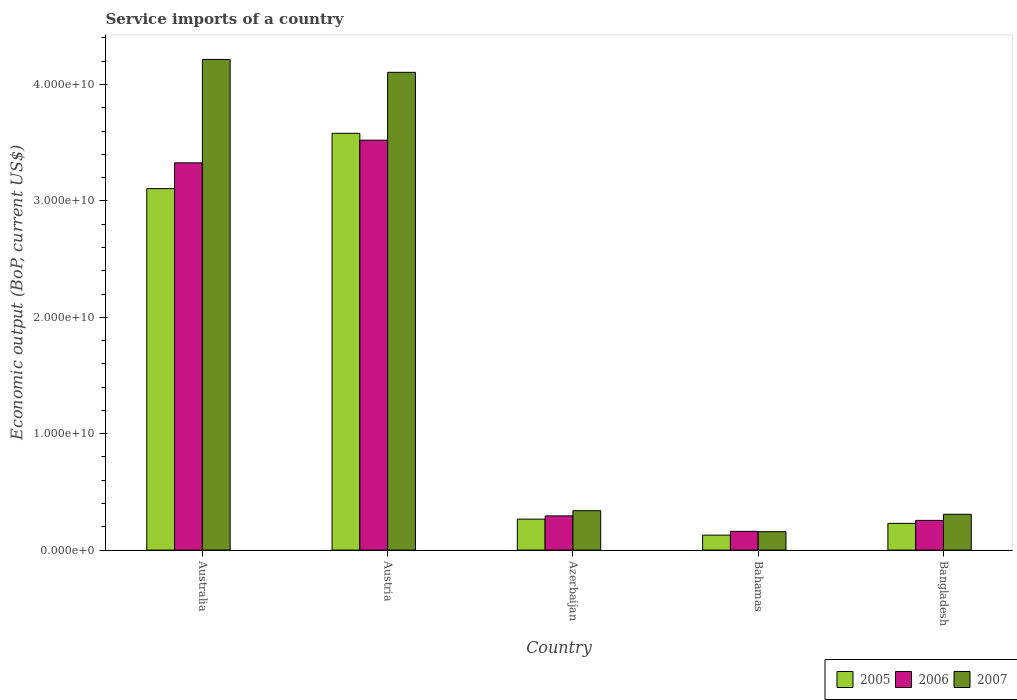How many different coloured bars are there?
Make the answer very short. 3. Are the number of bars per tick equal to the number of legend labels?
Give a very brief answer. Yes. How many bars are there on the 5th tick from the left?
Keep it short and to the point. 3. How many bars are there on the 2nd tick from the right?
Make the answer very short. 3. What is the label of the 1st group of bars from the left?
Offer a very short reply. Australia. What is the service imports in 2005 in Bangladesh?
Your response must be concise. 2.30e+09. Across all countries, what is the maximum service imports in 2007?
Offer a very short reply. 4.22e+1. Across all countries, what is the minimum service imports in 2006?
Your response must be concise. 1.61e+09. In which country was the service imports in 2005 minimum?
Provide a short and direct response. Bahamas. What is the total service imports in 2006 in the graph?
Provide a short and direct response. 7.56e+1. What is the difference between the service imports in 2007 in Austria and that in Bangladesh?
Provide a succinct answer. 3.80e+1. What is the difference between the service imports in 2007 in Azerbaijan and the service imports in 2006 in Bangladesh?
Make the answer very short. 8.32e+08. What is the average service imports in 2006 per country?
Keep it short and to the point. 1.51e+1. What is the difference between the service imports of/in 2005 and service imports of/in 2006 in Bahamas?
Your answer should be compact. -3.24e+08. In how many countries, is the service imports in 2007 greater than 2000000000 US$?
Provide a succinct answer. 4. What is the ratio of the service imports in 2007 in Azerbaijan to that in Bangladesh?
Your answer should be compact. 1.1. Is the difference between the service imports in 2005 in Australia and Bangladesh greater than the difference between the service imports in 2006 in Australia and Bangladesh?
Provide a short and direct response. No. What is the difference between the highest and the second highest service imports in 2006?
Provide a short and direct response. 3.23e+1. What is the difference between the highest and the lowest service imports in 2006?
Give a very brief answer. 3.36e+1. In how many countries, is the service imports in 2005 greater than the average service imports in 2005 taken over all countries?
Make the answer very short. 2. Is the sum of the service imports in 2005 in Australia and Bahamas greater than the maximum service imports in 2006 across all countries?
Give a very brief answer. No. Is it the case that in every country, the sum of the service imports in 2006 and service imports in 2007 is greater than the service imports in 2005?
Provide a succinct answer. Yes. What is the difference between two consecutive major ticks on the Y-axis?
Provide a succinct answer. 1.00e+1. Are the values on the major ticks of Y-axis written in scientific E-notation?
Provide a short and direct response. Yes. Does the graph contain any zero values?
Your response must be concise. No. Does the graph contain grids?
Your response must be concise. No. How many legend labels are there?
Ensure brevity in your answer.  3. How are the legend labels stacked?
Make the answer very short. Horizontal. What is the title of the graph?
Your answer should be very brief. Service imports of a country. What is the label or title of the Y-axis?
Your answer should be very brief. Economic output (BoP, current US$). What is the Economic output (BoP, current US$) in 2005 in Australia?
Your response must be concise. 3.11e+1. What is the Economic output (BoP, current US$) in 2006 in Australia?
Ensure brevity in your answer.  3.33e+1. What is the Economic output (BoP, current US$) in 2007 in Australia?
Keep it short and to the point. 4.22e+1. What is the Economic output (BoP, current US$) in 2005 in Austria?
Provide a succinct answer. 3.58e+1. What is the Economic output (BoP, current US$) of 2006 in Austria?
Offer a terse response. 3.52e+1. What is the Economic output (BoP, current US$) in 2007 in Austria?
Keep it short and to the point. 4.10e+1. What is the Economic output (BoP, current US$) of 2005 in Azerbaijan?
Your answer should be very brief. 2.66e+09. What is the Economic output (BoP, current US$) in 2006 in Azerbaijan?
Provide a succinct answer. 2.94e+09. What is the Economic output (BoP, current US$) in 2007 in Azerbaijan?
Provide a succinct answer. 3.39e+09. What is the Economic output (BoP, current US$) of 2005 in Bahamas?
Your answer should be compact. 1.29e+09. What is the Economic output (BoP, current US$) in 2006 in Bahamas?
Your response must be concise. 1.61e+09. What is the Economic output (BoP, current US$) of 2007 in Bahamas?
Provide a short and direct response. 1.58e+09. What is the Economic output (BoP, current US$) of 2005 in Bangladesh?
Your response must be concise. 2.30e+09. What is the Economic output (BoP, current US$) of 2006 in Bangladesh?
Your answer should be very brief. 2.55e+09. What is the Economic output (BoP, current US$) in 2007 in Bangladesh?
Provide a succinct answer. 3.08e+09. Across all countries, what is the maximum Economic output (BoP, current US$) of 2005?
Offer a very short reply. 3.58e+1. Across all countries, what is the maximum Economic output (BoP, current US$) in 2006?
Your answer should be very brief. 3.52e+1. Across all countries, what is the maximum Economic output (BoP, current US$) of 2007?
Your answer should be very brief. 4.22e+1. Across all countries, what is the minimum Economic output (BoP, current US$) in 2005?
Make the answer very short. 1.29e+09. Across all countries, what is the minimum Economic output (BoP, current US$) in 2006?
Give a very brief answer. 1.61e+09. Across all countries, what is the minimum Economic output (BoP, current US$) in 2007?
Offer a terse response. 1.58e+09. What is the total Economic output (BoP, current US$) in 2005 in the graph?
Your answer should be compact. 7.31e+1. What is the total Economic output (BoP, current US$) in 2006 in the graph?
Keep it short and to the point. 7.56e+1. What is the total Economic output (BoP, current US$) of 2007 in the graph?
Provide a succinct answer. 9.12e+1. What is the difference between the Economic output (BoP, current US$) of 2005 in Australia and that in Austria?
Your answer should be compact. -4.75e+09. What is the difference between the Economic output (BoP, current US$) of 2006 in Australia and that in Austria?
Your answer should be compact. -1.95e+09. What is the difference between the Economic output (BoP, current US$) in 2007 in Australia and that in Austria?
Offer a terse response. 1.11e+09. What is the difference between the Economic output (BoP, current US$) of 2005 in Australia and that in Azerbaijan?
Provide a succinct answer. 2.84e+1. What is the difference between the Economic output (BoP, current US$) in 2006 in Australia and that in Azerbaijan?
Your answer should be compact. 3.03e+1. What is the difference between the Economic output (BoP, current US$) of 2007 in Australia and that in Azerbaijan?
Ensure brevity in your answer.  3.88e+1. What is the difference between the Economic output (BoP, current US$) of 2005 in Australia and that in Bahamas?
Offer a very short reply. 2.98e+1. What is the difference between the Economic output (BoP, current US$) in 2006 in Australia and that in Bahamas?
Your answer should be compact. 3.17e+1. What is the difference between the Economic output (BoP, current US$) of 2007 in Australia and that in Bahamas?
Your answer should be compact. 4.06e+1. What is the difference between the Economic output (BoP, current US$) in 2005 in Australia and that in Bangladesh?
Offer a terse response. 2.88e+1. What is the difference between the Economic output (BoP, current US$) in 2006 in Australia and that in Bangladesh?
Offer a terse response. 3.07e+1. What is the difference between the Economic output (BoP, current US$) in 2007 in Australia and that in Bangladesh?
Your answer should be very brief. 3.91e+1. What is the difference between the Economic output (BoP, current US$) in 2005 in Austria and that in Azerbaijan?
Make the answer very short. 3.31e+1. What is the difference between the Economic output (BoP, current US$) of 2006 in Austria and that in Azerbaijan?
Keep it short and to the point. 3.23e+1. What is the difference between the Economic output (BoP, current US$) of 2007 in Austria and that in Azerbaijan?
Ensure brevity in your answer.  3.77e+1. What is the difference between the Economic output (BoP, current US$) in 2005 in Austria and that in Bahamas?
Make the answer very short. 3.45e+1. What is the difference between the Economic output (BoP, current US$) of 2006 in Austria and that in Bahamas?
Make the answer very short. 3.36e+1. What is the difference between the Economic output (BoP, current US$) in 2007 in Austria and that in Bahamas?
Offer a very short reply. 3.95e+1. What is the difference between the Economic output (BoP, current US$) in 2005 in Austria and that in Bangladesh?
Provide a succinct answer. 3.35e+1. What is the difference between the Economic output (BoP, current US$) in 2006 in Austria and that in Bangladesh?
Ensure brevity in your answer.  3.27e+1. What is the difference between the Economic output (BoP, current US$) in 2007 in Austria and that in Bangladesh?
Offer a terse response. 3.80e+1. What is the difference between the Economic output (BoP, current US$) of 2005 in Azerbaijan and that in Bahamas?
Offer a very short reply. 1.37e+09. What is the difference between the Economic output (BoP, current US$) in 2006 in Azerbaijan and that in Bahamas?
Your response must be concise. 1.33e+09. What is the difference between the Economic output (BoP, current US$) in 2007 in Azerbaijan and that in Bahamas?
Your response must be concise. 1.81e+09. What is the difference between the Economic output (BoP, current US$) in 2005 in Azerbaijan and that in Bangladesh?
Offer a very short reply. 3.61e+08. What is the difference between the Economic output (BoP, current US$) in 2006 in Azerbaijan and that in Bangladesh?
Give a very brief answer. 3.85e+08. What is the difference between the Economic output (BoP, current US$) of 2007 in Azerbaijan and that in Bangladesh?
Provide a succinct answer. 3.06e+08. What is the difference between the Economic output (BoP, current US$) of 2005 in Bahamas and that in Bangladesh?
Your response must be concise. -1.01e+09. What is the difference between the Economic output (BoP, current US$) of 2006 in Bahamas and that in Bangladesh?
Offer a terse response. -9.43e+08. What is the difference between the Economic output (BoP, current US$) of 2007 in Bahamas and that in Bangladesh?
Provide a short and direct response. -1.50e+09. What is the difference between the Economic output (BoP, current US$) in 2005 in Australia and the Economic output (BoP, current US$) in 2006 in Austria?
Offer a terse response. -4.16e+09. What is the difference between the Economic output (BoP, current US$) of 2005 in Australia and the Economic output (BoP, current US$) of 2007 in Austria?
Offer a very short reply. -9.99e+09. What is the difference between the Economic output (BoP, current US$) of 2006 in Australia and the Economic output (BoP, current US$) of 2007 in Austria?
Give a very brief answer. -7.78e+09. What is the difference between the Economic output (BoP, current US$) of 2005 in Australia and the Economic output (BoP, current US$) of 2006 in Azerbaijan?
Keep it short and to the point. 2.81e+1. What is the difference between the Economic output (BoP, current US$) of 2005 in Australia and the Economic output (BoP, current US$) of 2007 in Azerbaijan?
Your response must be concise. 2.77e+1. What is the difference between the Economic output (BoP, current US$) of 2006 in Australia and the Economic output (BoP, current US$) of 2007 in Azerbaijan?
Offer a very short reply. 2.99e+1. What is the difference between the Economic output (BoP, current US$) in 2005 in Australia and the Economic output (BoP, current US$) in 2006 in Bahamas?
Provide a succinct answer. 2.94e+1. What is the difference between the Economic output (BoP, current US$) of 2005 in Australia and the Economic output (BoP, current US$) of 2007 in Bahamas?
Make the answer very short. 2.95e+1. What is the difference between the Economic output (BoP, current US$) in 2006 in Australia and the Economic output (BoP, current US$) in 2007 in Bahamas?
Keep it short and to the point. 3.17e+1. What is the difference between the Economic output (BoP, current US$) of 2005 in Australia and the Economic output (BoP, current US$) of 2006 in Bangladesh?
Make the answer very short. 2.85e+1. What is the difference between the Economic output (BoP, current US$) in 2005 in Australia and the Economic output (BoP, current US$) in 2007 in Bangladesh?
Your response must be concise. 2.80e+1. What is the difference between the Economic output (BoP, current US$) of 2006 in Australia and the Economic output (BoP, current US$) of 2007 in Bangladesh?
Make the answer very short. 3.02e+1. What is the difference between the Economic output (BoP, current US$) in 2005 in Austria and the Economic output (BoP, current US$) in 2006 in Azerbaijan?
Your answer should be very brief. 3.29e+1. What is the difference between the Economic output (BoP, current US$) of 2005 in Austria and the Economic output (BoP, current US$) of 2007 in Azerbaijan?
Your response must be concise. 3.24e+1. What is the difference between the Economic output (BoP, current US$) in 2006 in Austria and the Economic output (BoP, current US$) in 2007 in Azerbaijan?
Your answer should be very brief. 3.18e+1. What is the difference between the Economic output (BoP, current US$) of 2005 in Austria and the Economic output (BoP, current US$) of 2006 in Bahamas?
Your response must be concise. 3.42e+1. What is the difference between the Economic output (BoP, current US$) in 2005 in Austria and the Economic output (BoP, current US$) in 2007 in Bahamas?
Offer a very short reply. 3.42e+1. What is the difference between the Economic output (BoP, current US$) in 2006 in Austria and the Economic output (BoP, current US$) in 2007 in Bahamas?
Provide a succinct answer. 3.36e+1. What is the difference between the Economic output (BoP, current US$) of 2005 in Austria and the Economic output (BoP, current US$) of 2006 in Bangladesh?
Provide a succinct answer. 3.33e+1. What is the difference between the Economic output (BoP, current US$) of 2005 in Austria and the Economic output (BoP, current US$) of 2007 in Bangladesh?
Give a very brief answer. 3.27e+1. What is the difference between the Economic output (BoP, current US$) in 2006 in Austria and the Economic output (BoP, current US$) in 2007 in Bangladesh?
Your answer should be compact. 3.21e+1. What is the difference between the Economic output (BoP, current US$) of 2005 in Azerbaijan and the Economic output (BoP, current US$) of 2006 in Bahamas?
Your response must be concise. 1.05e+09. What is the difference between the Economic output (BoP, current US$) in 2005 in Azerbaijan and the Economic output (BoP, current US$) in 2007 in Bahamas?
Give a very brief answer. 1.08e+09. What is the difference between the Economic output (BoP, current US$) of 2006 in Azerbaijan and the Economic output (BoP, current US$) of 2007 in Bahamas?
Offer a very short reply. 1.36e+09. What is the difference between the Economic output (BoP, current US$) in 2005 in Azerbaijan and the Economic output (BoP, current US$) in 2006 in Bangladesh?
Your answer should be compact. 1.05e+08. What is the difference between the Economic output (BoP, current US$) in 2005 in Azerbaijan and the Economic output (BoP, current US$) in 2007 in Bangladesh?
Give a very brief answer. -4.20e+08. What is the difference between the Economic output (BoP, current US$) of 2006 in Azerbaijan and the Economic output (BoP, current US$) of 2007 in Bangladesh?
Your answer should be compact. -1.41e+08. What is the difference between the Economic output (BoP, current US$) of 2005 in Bahamas and the Economic output (BoP, current US$) of 2006 in Bangladesh?
Provide a short and direct response. -1.27e+09. What is the difference between the Economic output (BoP, current US$) of 2005 in Bahamas and the Economic output (BoP, current US$) of 2007 in Bangladesh?
Give a very brief answer. -1.79e+09. What is the difference between the Economic output (BoP, current US$) in 2006 in Bahamas and the Economic output (BoP, current US$) in 2007 in Bangladesh?
Provide a short and direct response. -1.47e+09. What is the average Economic output (BoP, current US$) in 2005 per country?
Offer a terse response. 1.46e+1. What is the average Economic output (BoP, current US$) of 2006 per country?
Offer a terse response. 1.51e+1. What is the average Economic output (BoP, current US$) of 2007 per country?
Offer a terse response. 1.82e+1. What is the difference between the Economic output (BoP, current US$) of 2005 and Economic output (BoP, current US$) of 2006 in Australia?
Provide a succinct answer. -2.21e+09. What is the difference between the Economic output (BoP, current US$) of 2005 and Economic output (BoP, current US$) of 2007 in Australia?
Offer a terse response. -1.11e+1. What is the difference between the Economic output (BoP, current US$) in 2006 and Economic output (BoP, current US$) in 2007 in Australia?
Your response must be concise. -8.89e+09. What is the difference between the Economic output (BoP, current US$) of 2005 and Economic output (BoP, current US$) of 2006 in Austria?
Ensure brevity in your answer.  5.90e+08. What is the difference between the Economic output (BoP, current US$) in 2005 and Economic output (BoP, current US$) in 2007 in Austria?
Give a very brief answer. -5.24e+09. What is the difference between the Economic output (BoP, current US$) in 2006 and Economic output (BoP, current US$) in 2007 in Austria?
Offer a very short reply. -5.83e+09. What is the difference between the Economic output (BoP, current US$) of 2005 and Economic output (BoP, current US$) of 2006 in Azerbaijan?
Offer a terse response. -2.80e+08. What is the difference between the Economic output (BoP, current US$) of 2005 and Economic output (BoP, current US$) of 2007 in Azerbaijan?
Make the answer very short. -7.26e+08. What is the difference between the Economic output (BoP, current US$) of 2006 and Economic output (BoP, current US$) of 2007 in Azerbaijan?
Your response must be concise. -4.47e+08. What is the difference between the Economic output (BoP, current US$) of 2005 and Economic output (BoP, current US$) of 2006 in Bahamas?
Your answer should be very brief. -3.24e+08. What is the difference between the Economic output (BoP, current US$) in 2005 and Economic output (BoP, current US$) in 2007 in Bahamas?
Provide a succinct answer. -2.93e+08. What is the difference between the Economic output (BoP, current US$) of 2006 and Economic output (BoP, current US$) of 2007 in Bahamas?
Offer a very short reply. 3.13e+07. What is the difference between the Economic output (BoP, current US$) of 2005 and Economic output (BoP, current US$) of 2006 in Bangladesh?
Your answer should be compact. -2.56e+08. What is the difference between the Economic output (BoP, current US$) of 2005 and Economic output (BoP, current US$) of 2007 in Bangladesh?
Your answer should be very brief. -7.82e+08. What is the difference between the Economic output (BoP, current US$) of 2006 and Economic output (BoP, current US$) of 2007 in Bangladesh?
Offer a very short reply. -5.26e+08. What is the ratio of the Economic output (BoP, current US$) of 2005 in Australia to that in Austria?
Provide a succinct answer. 0.87. What is the ratio of the Economic output (BoP, current US$) in 2006 in Australia to that in Austria?
Your answer should be compact. 0.94. What is the ratio of the Economic output (BoP, current US$) in 2007 in Australia to that in Austria?
Your response must be concise. 1.03. What is the ratio of the Economic output (BoP, current US$) in 2005 in Australia to that in Azerbaijan?
Offer a very short reply. 11.68. What is the ratio of the Economic output (BoP, current US$) in 2006 in Australia to that in Azerbaijan?
Your answer should be very brief. 11.32. What is the ratio of the Economic output (BoP, current US$) of 2007 in Australia to that in Azerbaijan?
Make the answer very short. 12.45. What is the ratio of the Economic output (BoP, current US$) in 2005 in Australia to that in Bahamas?
Provide a short and direct response. 24.14. What is the ratio of the Economic output (BoP, current US$) in 2006 in Australia to that in Bahamas?
Give a very brief answer. 20.65. What is the ratio of the Economic output (BoP, current US$) of 2007 in Australia to that in Bahamas?
Give a very brief answer. 26.69. What is the ratio of the Economic output (BoP, current US$) of 2005 in Australia to that in Bangladesh?
Your answer should be very brief. 13.52. What is the ratio of the Economic output (BoP, current US$) of 2006 in Australia to that in Bangladesh?
Keep it short and to the point. 13.03. What is the ratio of the Economic output (BoP, current US$) in 2007 in Australia to that in Bangladesh?
Your answer should be compact. 13.69. What is the ratio of the Economic output (BoP, current US$) of 2005 in Austria to that in Azerbaijan?
Your response must be concise. 13.47. What is the ratio of the Economic output (BoP, current US$) in 2006 in Austria to that in Azerbaijan?
Offer a very short reply. 11.98. What is the ratio of the Economic output (BoP, current US$) of 2007 in Austria to that in Azerbaijan?
Offer a very short reply. 12.13. What is the ratio of the Economic output (BoP, current US$) of 2005 in Austria to that in Bahamas?
Your answer should be compact. 27.83. What is the ratio of the Economic output (BoP, current US$) of 2006 in Austria to that in Bahamas?
Offer a very short reply. 21.86. What is the ratio of the Economic output (BoP, current US$) in 2007 in Austria to that in Bahamas?
Make the answer very short. 25.99. What is the ratio of the Economic output (BoP, current US$) of 2005 in Austria to that in Bangladesh?
Give a very brief answer. 15.59. What is the ratio of the Economic output (BoP, current US$) of 2006 in Austria to that in Bangladesh?
Keep it short and to the point. 13.79. What is the ratio of the Economic output (BoP, current US$) of 2007 in Austria to that in Bangladesh?
Make the answer very short. 13.33. What is the ratio of the Economic output (BoP, current US$) in 2005 in Azerbaijan to that in Bahamas?
Give a very brief answer. 2.07. What is the ratio of the Economic output (BoP, current US$) of 2006 in Azerbaijan to that in Bahamas?
Offer a very short reply. 1.82. What is the ratio of the Economic output (BoP, current US$) in 2007 in Azerbaijan to that in Bahamas?
Offer a very short reply. 2.14. What is the ratio of the Economic output (BoP, current US$) in 2005 in Azerbaijan to that in Bangladesh?
Provide a short and direct response. 1.16. What is the ratio of the Economic output (BoP, current US$) in 2006 in Azerbaijan to that in Bangladesh?
Provide a succinct answer. 1.15. What is the ratio of the Economic output (BoP, current US$) of 2007 in Azerbaijan to that in Bangladesh?
Your answer should be very brief. 1.1. What is the ratio of the Economic output (BoP, current US$) of 2005 in Bahamas to that in Bangladesh?
Your answer should be compact. 0.56. What is the ratio of the Economic output (BoP, current US$) of 2006 in Bahamas to that in Bangladesh?
Offer a terse response. 0.63. What is the ratio of the Economic output (BoP, current US$) of 2007 in Bahamas to that in Bangladesh?
Your answer should be very brief. 0.51. What is the difference between the highest and the second highest Economic output (BoP, current US$) of 2005?
Provide a short and direct response. 4.75e+09. What is the difference between the highest and the second highest Economic output (BoP, current US$) in 2006?
Make the answer very short. 1.95e+09. What is the difference between the highest and the second highest Economic output (BoP, current US$) in 2007?
Make the answer very short. 1.11e+09. What is the difference between the highest and the lowest Economic output (BoP, current US$) of 2005?
Make the answer very short. 3.45e+1. What is the difference between the highest and the lowest Economic output (BoP, current US$) in 2006?
Give a very brief answer. 3.36e+1. What is the difference between the highest and the lowest Economic output (BoP, current US$) in 2007?
Your answer should be compact. 4.06e+1. 